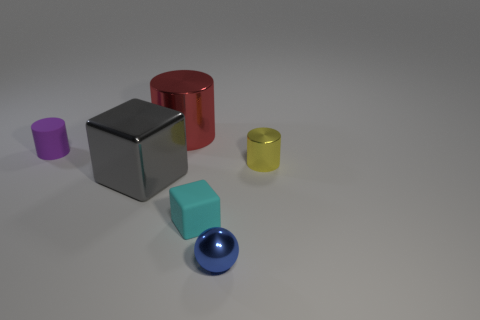Subtract all tiny rubber cylinders. How many cylinders are left? 2 Add 3 tiny green shiny cylinders. How many objects exist? 9 Subtract all purple cylinders. How many cylinders are left? 2 Subtract 1 spheres. How many spheres are left? 0 Subtract 0 blue cubes. How many objects are left? 6 Subtract all blocks. How many objects are left? 4 Subtract all green cylinders. Subtract all gray blocks. How many cylinders are left? 3 Subtract all small green spheres. Subtract all cyan blocks. How many objects are left? 5 Add 6 small blue spheres. How many small blue spheres are left? 7 Add 5 tiny blue matte things. How many tiny blue matte things exist? 5 